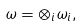Convert formula to latex. <formula><loc_0><loc_0><loc_500><loc_500>\omega = \otimes _ { i } \omega _ { i } ,</formula> 